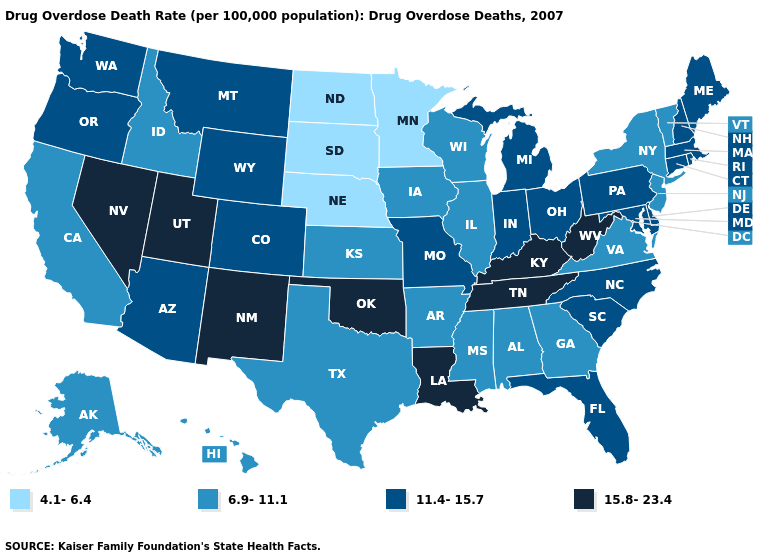Among the states that border Nevada , does Idaho have the lowest value?
Be succinct. Yes. What is the lowest value in states that border New Hampshire?
Concise answer only. 6.9-11.1. Name the states that have a value in the range 15.8-23.4?
Write a very short answer. Kentucky, Louisiana, Nevada, New Mexico, Oklahoma, Tennessee, Utah, West Virginia. Does West Virginia have a higher value than Oregon?
Write a very short answer. Yes. What is the value of Massachusetts?
Quick response, please. 11.4-15.7. Does New Hampshire have the highest value in the USA?
Concise answer only. No. Does the map have missing data?
Answer briefly. No. Name the states that have a value in the range 11.4-15.7?
Write a very short answer. Arizona, Colorado, Connecticut, Delaware, Florida, Indiana, Maine, Maryland, Massachusetts, Michigan, Missouri, Montana, New Hampshire, North Carolina, Ohio, Oregon, Pennsylvania, Rhode Island, South Carolina, Washington, Wyoming. What is the lowest value in the USA?
Concise answer only. 4.1-6.4. What is the value of Ohio?
Give a very brief answer. 11.4-15.7. Which states have the lowest value in the South?
Short answer required. Alabama, Arkansas, Georgia, Mississippi, Texas, Virginia. Does Arizona have the lowest value in the USA?
Concise answer only. No. Does Kansas have the highest value in the MidWest?
Quick response, please. No. Does the first symbol in the legend represent the smallest category?
Give a very brief answer. Yes. Does Arizona have the highest value in the West?
Quick response, please. No. 